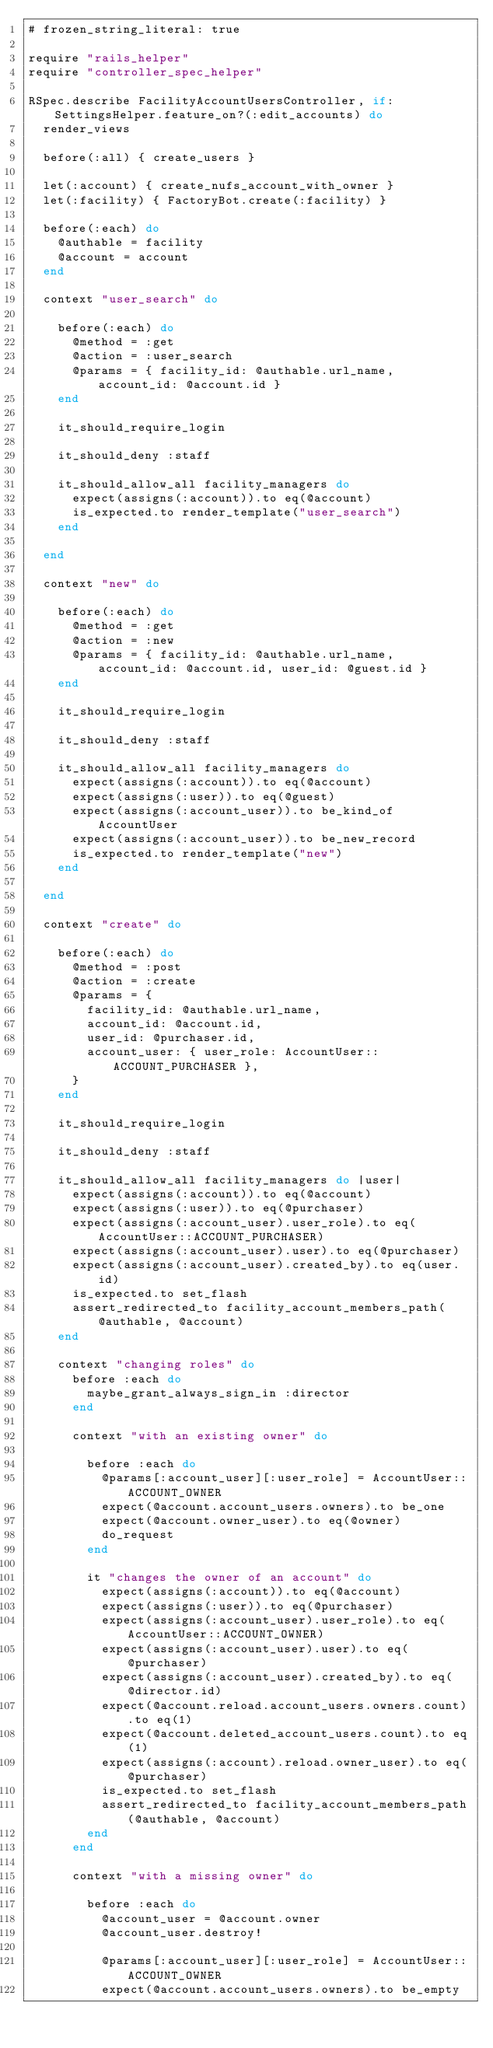Convert code to text. <code><loc_0><loc_0><loc_500><loc_500><_Ruby_># frozen_string_literal: true

require "rails_helper"
require "controller_spec_helper"

RSpec.describe FacilityAccountUsersController, if: SettingsHelper.feature_on?(:edit_accounts) do
  render_views

  before(:all) { create_users }

  let(:account) { create_nufs_account_with_owner }
  let(:facility) { FactoryBot.create(:facility) }

  before(:each) do
    @authable = facility
    @account = account
  end

  context "user_search" do

    before(:each) do
      @method = :get
      @action = :user_search
      @params = { facility_id: @authable.url_name, account_id: @account.id }
    end

    it_should_require_login

    it_should_deny :staff

    it_should_allow_all facility_managers do
      expect(assigns(:account)).to eq(@account)
      is_expected.to render_template("user_search")
    end

  end

  context "new" do

    before(:each) do
      @method = :get
      @action = :new
      @params = { facility_id: @authable.url_name, account_id: @account.id, user_id: @guest.id }
    end

    it_should_require_login

    it_should_deny :staff

    it_should_allow_all facility_managers do
      expect(assigns(:account)).to eq(@account)
      expect(assigns(:user)).to eq(@guest)
      expect(assigns(:account_user)).to be_kind_of AccountUser
      expect(assigns(:account_user)).to be_new_record
      is_expected.to render_template("new")
    end

  end

  context "create" do

    before(:each) do
      @method = :post
      @action = :create
      @params = {
        facility_id: @authable.url_name,
        account_id: @account.id,
        user_id: @purchaser.id,
        account_user: { user_role: AccountUser::ACCOUNT_PURCHASER },
      }
    end

    it_should_require_login

    it_should_deny :staff

    it_should_allow_all facility_managers do |user|
      expect(assigns(:account)).to eq(@account)
      expect(assigns(:user)).to eq(@purchaser)
      expect(assigns(:account_user).user_role).to eq(AccountUser::ACCOUNT_PURCHASER)
      expect(assigns(:account_user).user).to eq(@purchaser)
      expect(assigns(:account_user).created_by).to eq(user.id)
      is_expected.to set_flash
      assert_redirected_to facility_account_members_path(@authable, @account)
    end

    context "changing roles" do
      before :each do
        maybe_grant_always_sign_in :director
      end

      context "with an existing owner" do

        before :each do
          @params[:account_user][:user_role] = AccountUser::ACCOUNT_OWNER
          expect(@account.account_users.owners).to be_one
          expect(@account.owner_user).to eq(@owner)
          do_request
        end

        it "changes the owner of an account" do
          expect(assigns(:account)).to eq(@account)
          expect(assigns(:user)).to eq(@purchaser)
          expect(assigns(:account_user).user_role).to eq(AccountUser::ACCOUNT_OWNER)
          expect(assigns(:account_user).user).to eq(@purchaser)
          expect(assigns(:account_user).created_by).to eq(@director.id)
          expect(@account.reload.account_users.owners.count).to eq(1)
          expect(@account.deleted_account_users.count).to eq(1)
          expect(assigns(:account).reload.owner_user).to eq(@purchaser)
          is_expected.to set_flash
          assert_redirected_to facility_account_members_path(@authable, @account)
        end
      end

      context "with a missing owner" do

        before :each do
          @account_user = @account.owner
          @account_user.destroy!

          @params[:account_user][:user_role] = AccountUser::ACCOUNT_OWNER
          expect(@account.account_users.owners).to be_empty</code> 